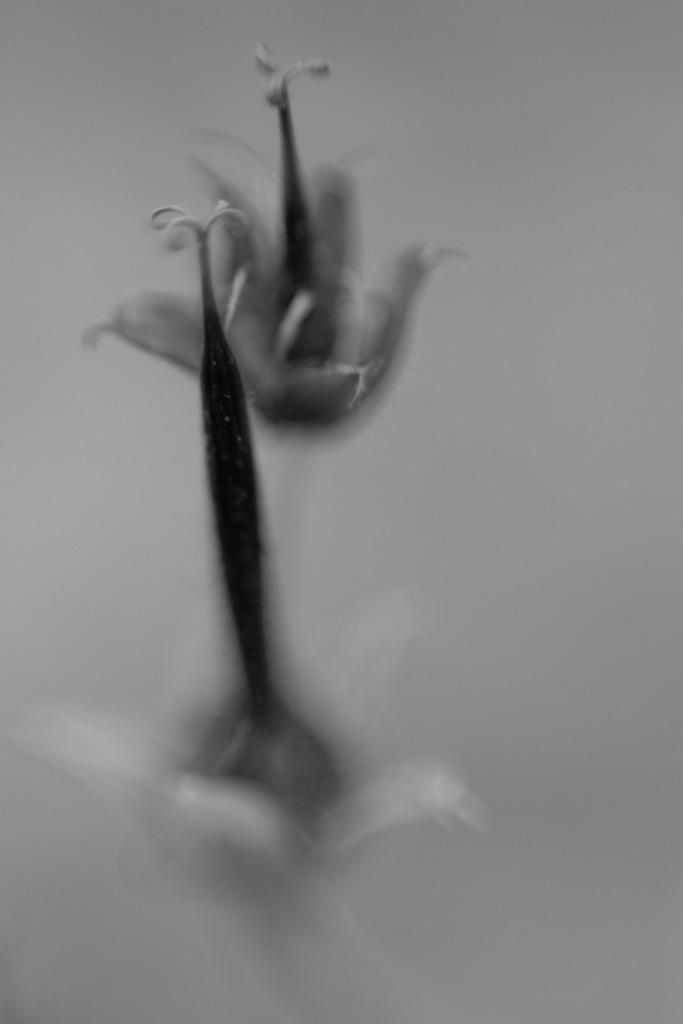What type of living organisms can be seen in the image? There are flowers in the image. How would you describe the appearance of the flowers? The flowers are blurry in the image. What type of hole can be seen in the image? There is no hole present in the image; it only features flowers. 